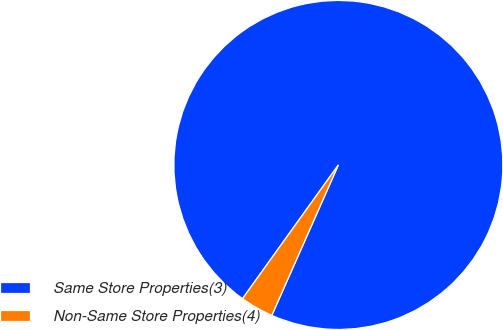Convert chart. <chart><loc_0><loc_0><loc_500><loc_500><pie_chart><fcel>Same Store Properties(3)<fcel>Non-Same Store Properties(4)<nl><fcel>96.73%<fcel>3.27%<nl></chart> 